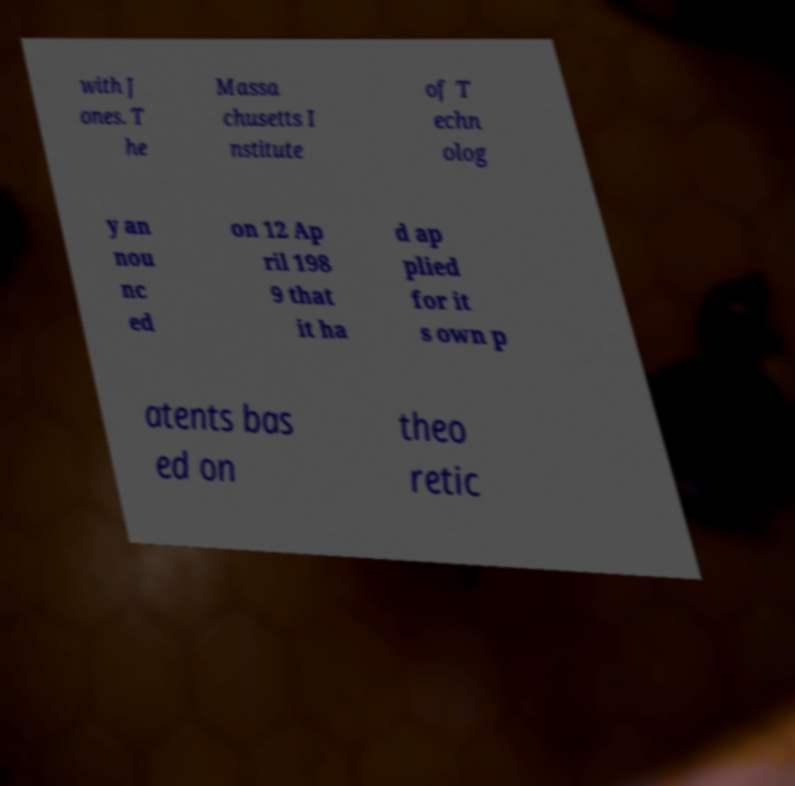Can you read and provide the text displayed in the image?This photo seems to have some interesting text. Can you extract and type it out for me? with J ones. T he Massa chusetts I nstitute of T echn olog y an nou nc ed on 12 Ap ril 198 9 that it ha d ap plied for it s own p atents bas ed on theo retic 